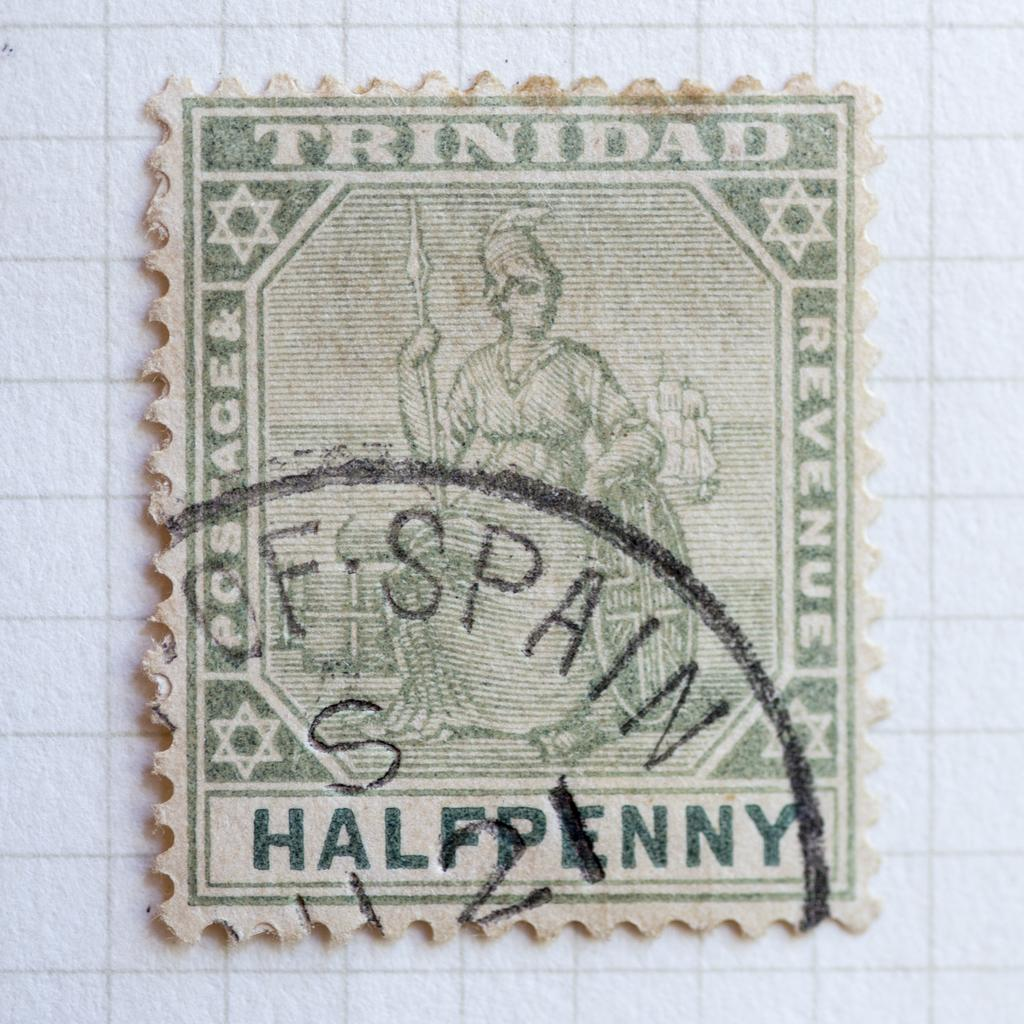What is the main object in the image? There is a stamp in the image. Where is the stamp located? The stamp is pasted on a paper. What type of flower is depicted on the stamp? There is no flower depicted on the stamp; the image only shows a stamp pasted on a paper. 